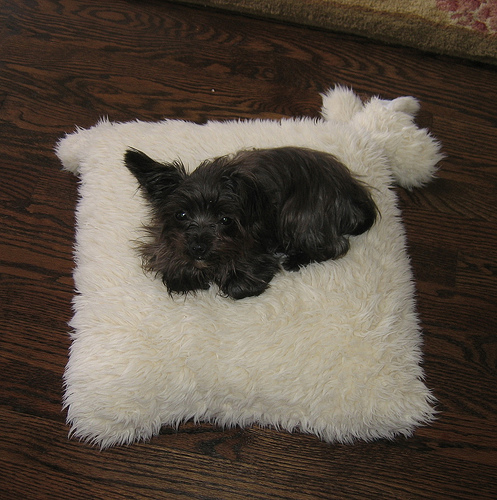<image>
Is there a dog to the left of the rug? No. The dog is not to the left of the rug. From this viewpoint, they have a different horizontal relationship. 